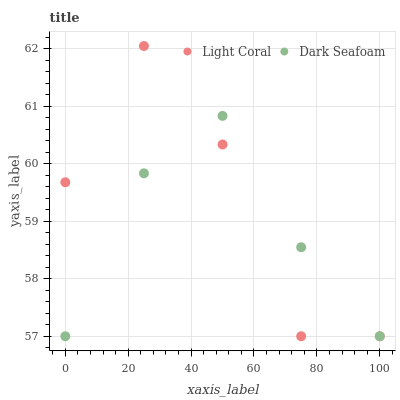Does Dark Seafoam have the minimum area under the curve?
Answer yes or no. Yes. Does Light Coral have the maximum area under the curve?
Answer yes or no. Yes. Does Dark Seafoam have the maximum area under the curve?
Answer yes or no. No. Is Dark Seafoam the smoothest?
Answer yes or no. Yes. Is Light Coral the roughest?
Answer yes or no. Yes. Is Dark Seafoam the roughest?
Answer yes or no. No. Does Light Coral have the lowest value?
Answer yes or no. Yes. Does Light Coral have the highest value?
Answer yes or no. Yes. Does Dark Seafoam have the highest value?
Answer yes or no. No. Does Dark Seafoam intersect Light Coral?
Answer yes or no. Yes. Is Dark Seafoam less than Light Coral?
Answer yes or no. No. Is Dark Seafoam greater than Light Coral?
Answer yes or no. No. 